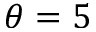Convert formula to latex. <formula><loc_0><loc_0><loc_500><loc_500>\theta = 5</formula> 